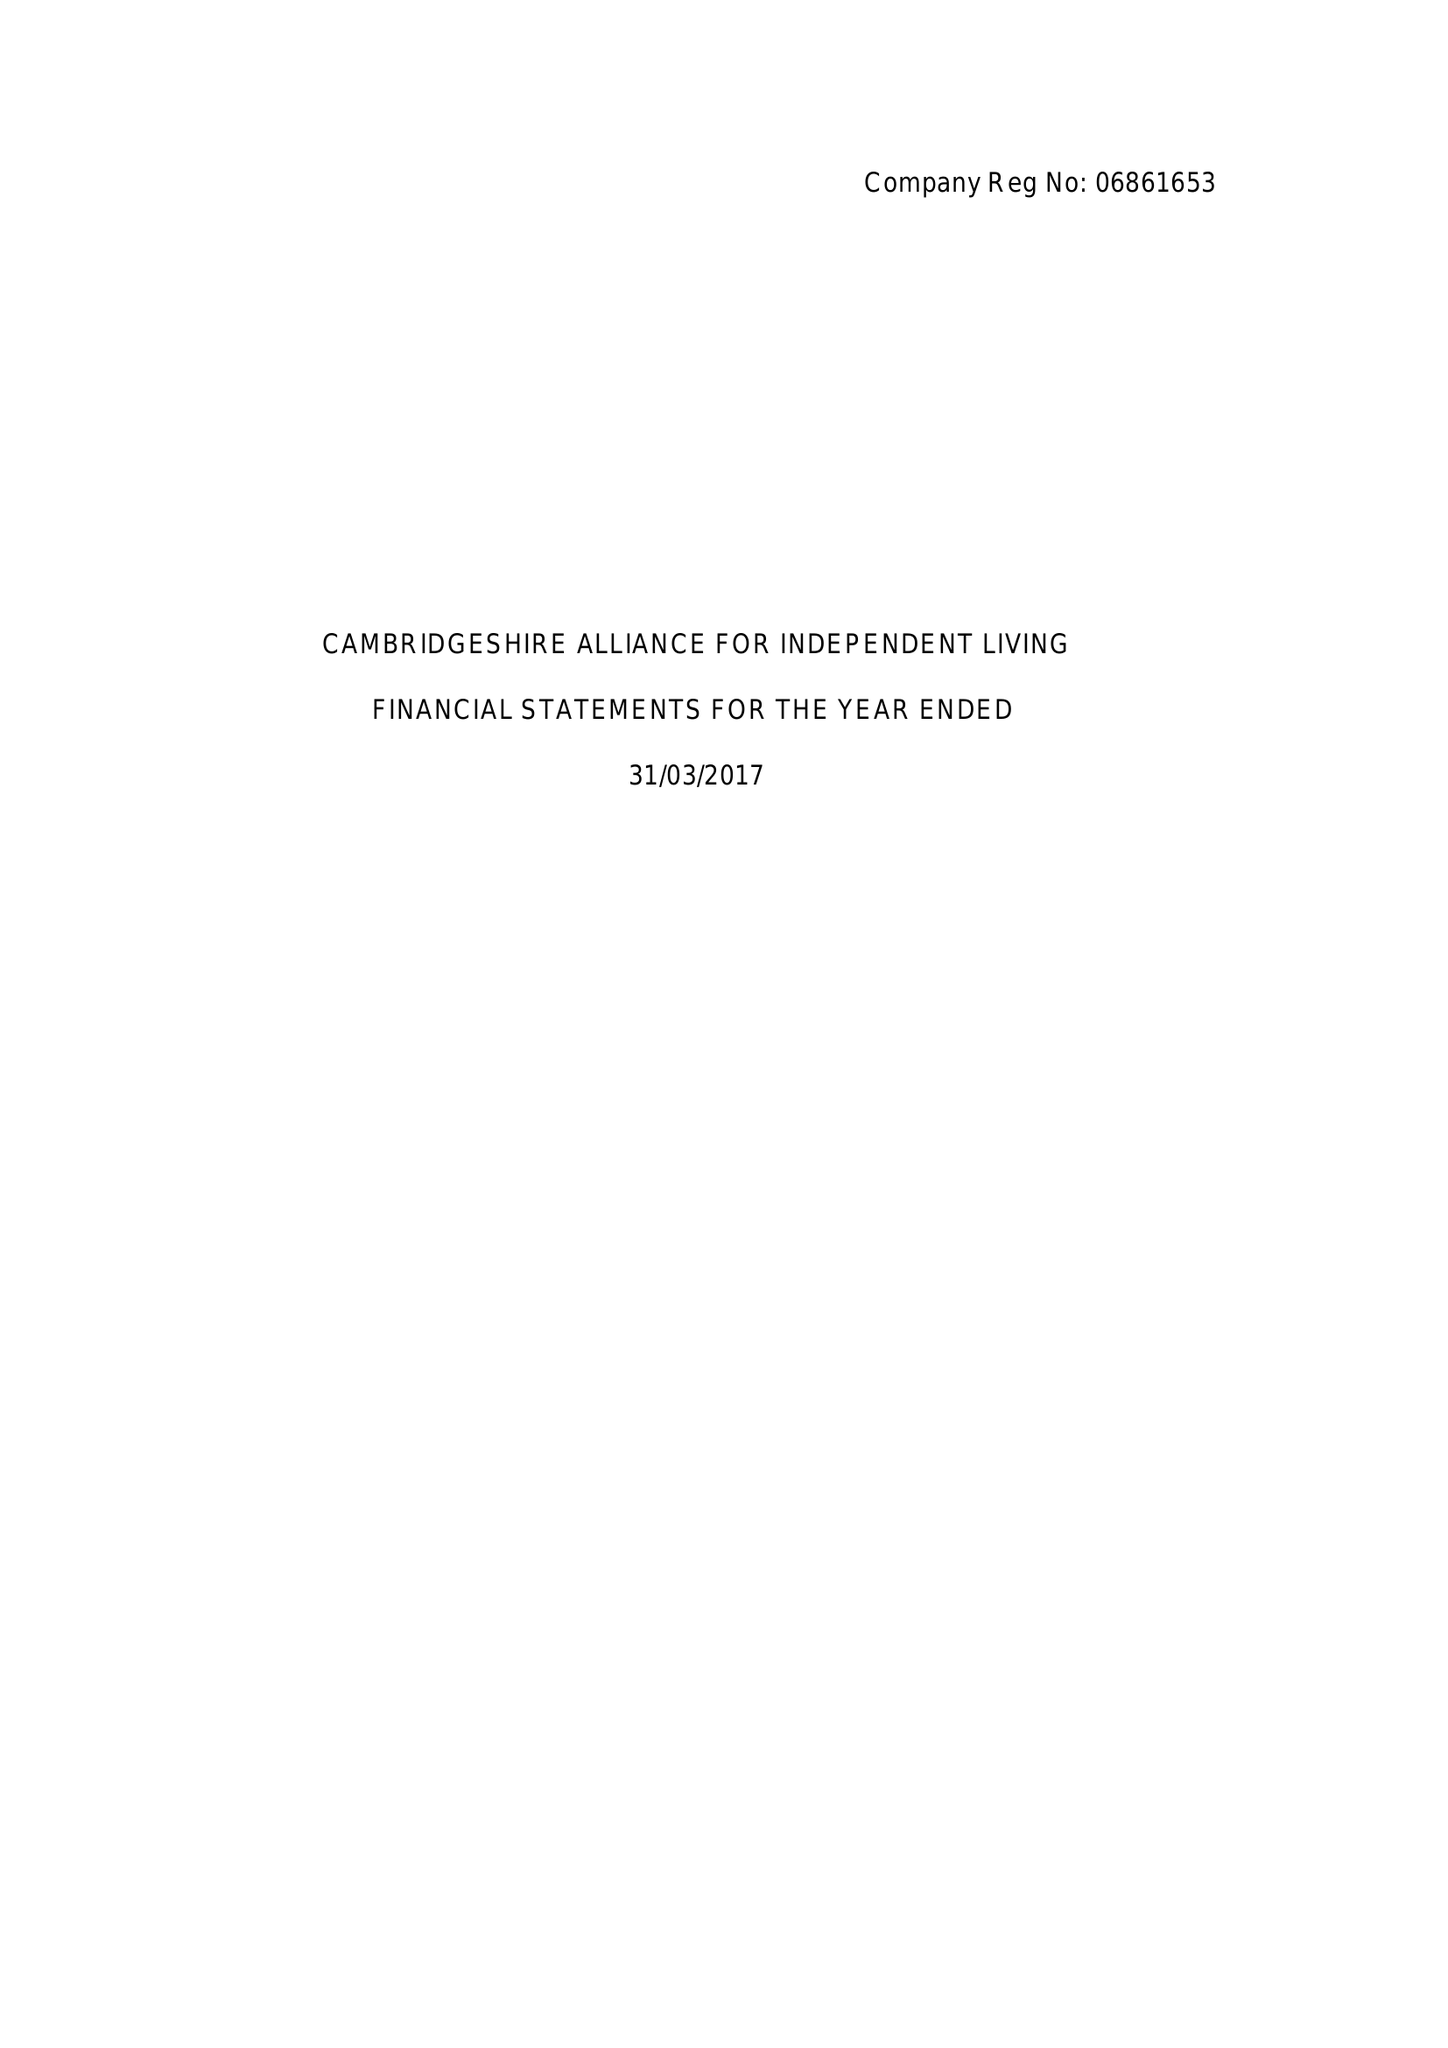What is the value for the address__street_line?
Answer the question using a single word or phrase. FEN ROAD 